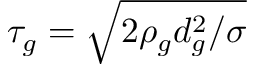<formula> <loc_0><loc_0><loc_500><loc_500>\tau _ { g } = \sqrt { 2 \rho _ { g } d _ { g } ^ { 2 } / \sigma }</formula> 